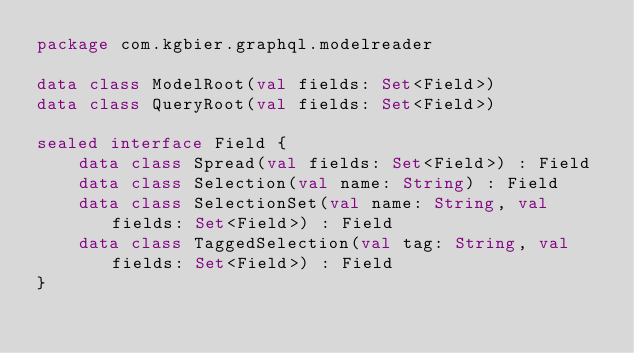<code> <loc_0><loc_0><loc_500><loc_500><_Kotlin_>package com.kgbier.graphql.modelreader

data class ModelRoot(val fields: Set<Field>)
data class QueryRoot(val fields: Set<Field>)

sealed interface Field {
    data class Spread(val fields: Set<Field>) : Field
    data class Selection(val name: String) : Field
    data class SelectionSet(val name: String, val fields: Set<Field>) : Field
    data class TaggedSelection(val tag: String, val fields: Set<Field>) : Field
}</code> 